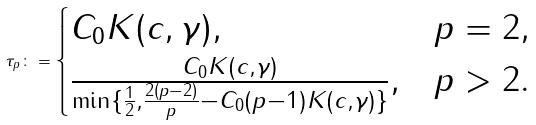<formula> <loc_0><loc_0><loc_500><loc_500>\tau _ { p } \colon = \begin{cases} C _ { 0 } K ( c , \gamma ) , & p = 2 , \\ \frac { C _ { 0 } K ( c , \gamma ) } { \min \{ \frac { 1 } { 2 } , \frac { 2 ( p - 2 ) } { p } - C _ { 0 } ( p - 1 ) K ( c , \gamma ) \} } , & p > 2 . \end{cases}</formula> 